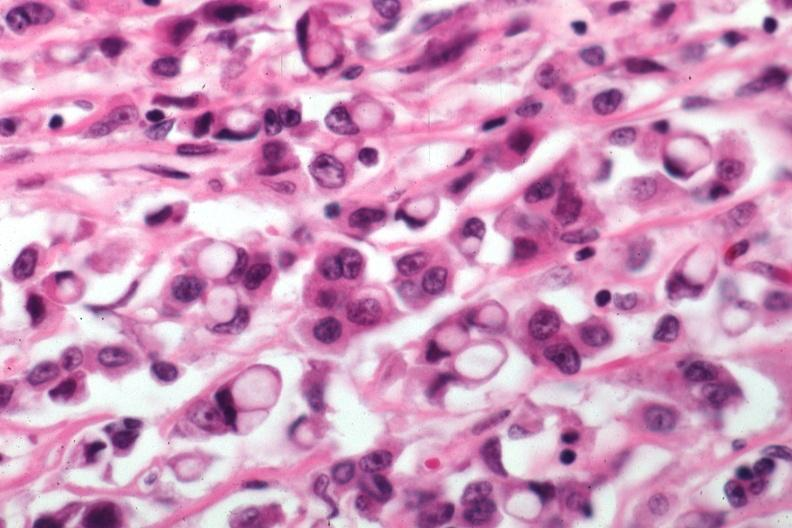s carcinoma present?
Answer the question using a single word or phrase. Yes 